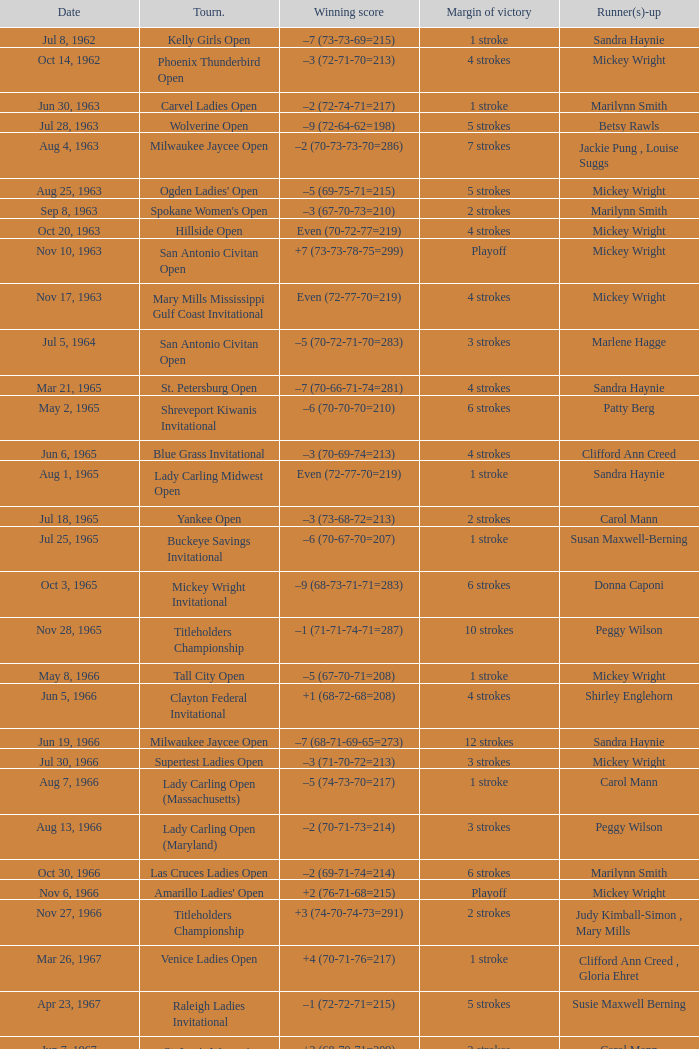What was the margin of victory on Apr 23, 1967? 5 strokes. 